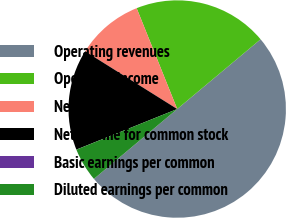Convert chart. <chart><loc_0><loc_0><loc_500><loc_500><pie_chart><fcel>Operating revenues<fcel>Operating income<fcel>Net income (a)<fcel>Net income for common stock<fcel>Basic earnings per common<fcel>Diluted earnings per common<nl><fcel>49.98%<fcel>20.0%<fcel>10.0%<fcel>15.0%<fcel>0.01%<fcel>5.01%<nl></chart> 